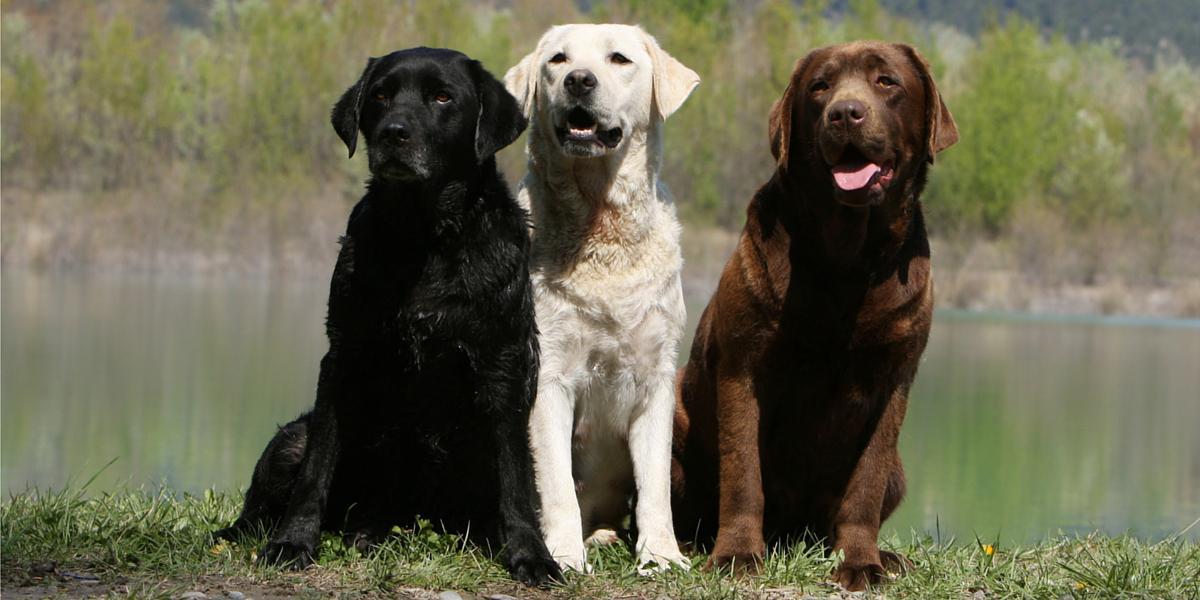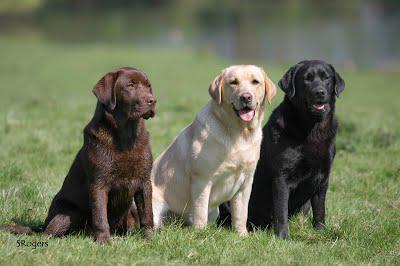The first image is the image on the left, the second image is the image on the right. Assess this claim about the two images: "Each image shows at least three labrador retriever dogs sitting upright in a horizontal row.". Correct or not? Answer yes or no. Yes. The first image is the image on the left, the second image is the image on the right. For the images displayed, is the sentence "Three dogs are sitting on the ground in the image on the left." factually correct? Answer yes or no. Yes. 